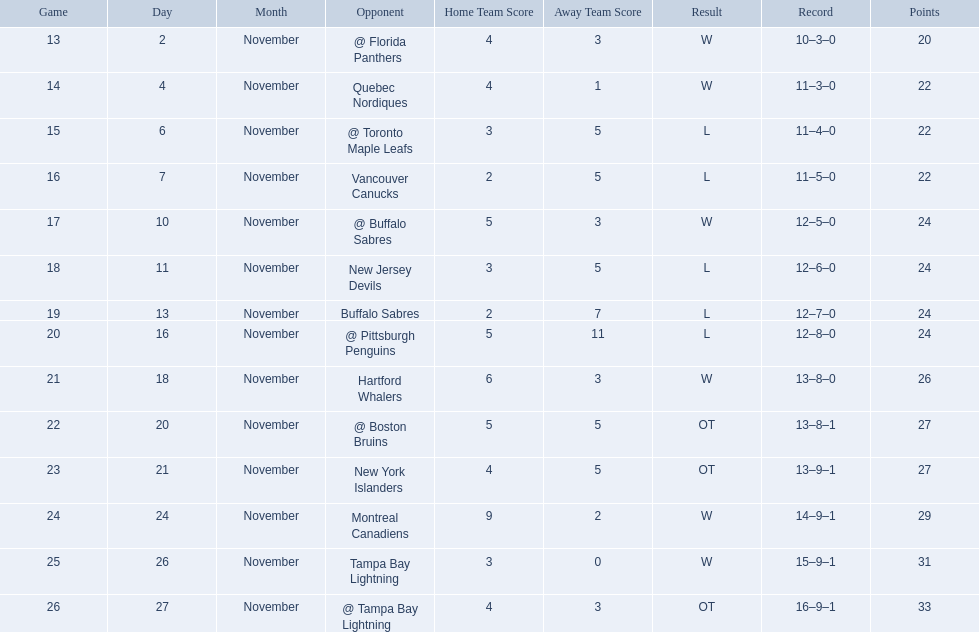Parse the full table. {'header': ['Game', 'Day', 'Month', 'Opponent', 'Home Team Score', 'Away Team Score', 'Result', 'Record', 'Points'], 'rows': [['13', '2', 'November', '@ Florida Panthers', '4', '3', 'W', '10–3–0', '20'], ['14', '4', 'November', 'Quebec Nordiques', '4', '1', 'W', '11–3–0', '22'], ['15', '6', 'November', '@ Toronto Maple Leafs', '3', '5', 'L', '11–4–0', '22'], ['16', '7', 'November', 'Vancouver Canucks', '2', '5', 'L', '11–5–0', '22'], ['17', '10', 'November', '@ Buffalo Sabres', '5', '3', 'W', '12–5–0', '24'], ['18', '11', 'November', 'New Jersey Devils', '3', '5', 'L', '12–6–0', '24'], ['19', '13', 'November', 'Buffalo Sabres', '2', '7', 'L', '12–7–0', '24'], ['20', '16', 'November', '@ Pittsburgh Penguins', '5', '11', 'L', '12–8–0', '24'], ['21', '18', 'November', 'Hartford Whalers', '6', '3', 'W', '13–8–0', '26'], ['22', '20', 'November', '@ Boston Bruins', '5', '5', 'OT', '13–8–1', '27'], ['23', '21', 'November', 'New York Islanders', '4', '5', 'OT', '13–9–1', '27'], ['24', '24', 'November', 'Montreal Canadiens', '9', '2', 'W', '14–9–1', '29'], ['25', '26', 'November', 'Tampa Bay Lightning', '3', '0', 'W', '15–9–1', '31'], ['26', '27', 'November', '@ Tampa Bay Lightning', '4', '3', 'OT', '16–9–1', '33']]} Who are all of the teams? @ Florida Panthers, Quebec Nordiques, @ Toronto Maple Leafs, Vancouver Canucks, @ Buffalo Sabres, New Jersey Devils, Buffalo Sabres, @ Pittsburgh Penguins, Hartford Whalers, @ Boston Bruins, New York Islanders, Montreal Canadiens, Tampa Bay Lightning. What games finished in overtime? 22, 23, 26. In game number 23, who did they face? New York Islanders. 